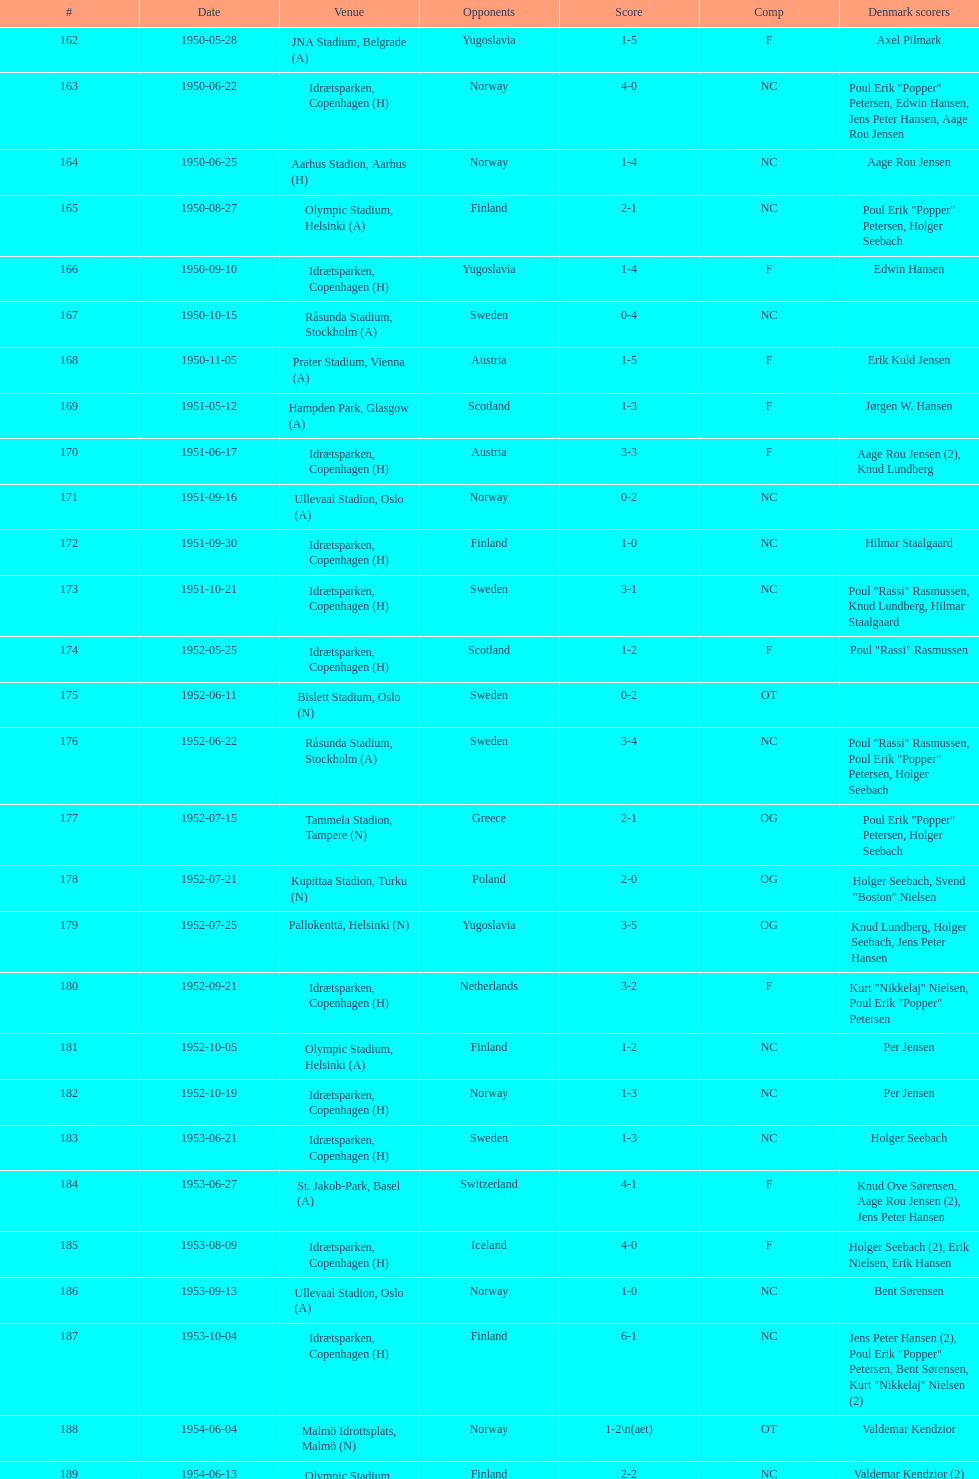How many times does nc show up in the comp column? 32. 